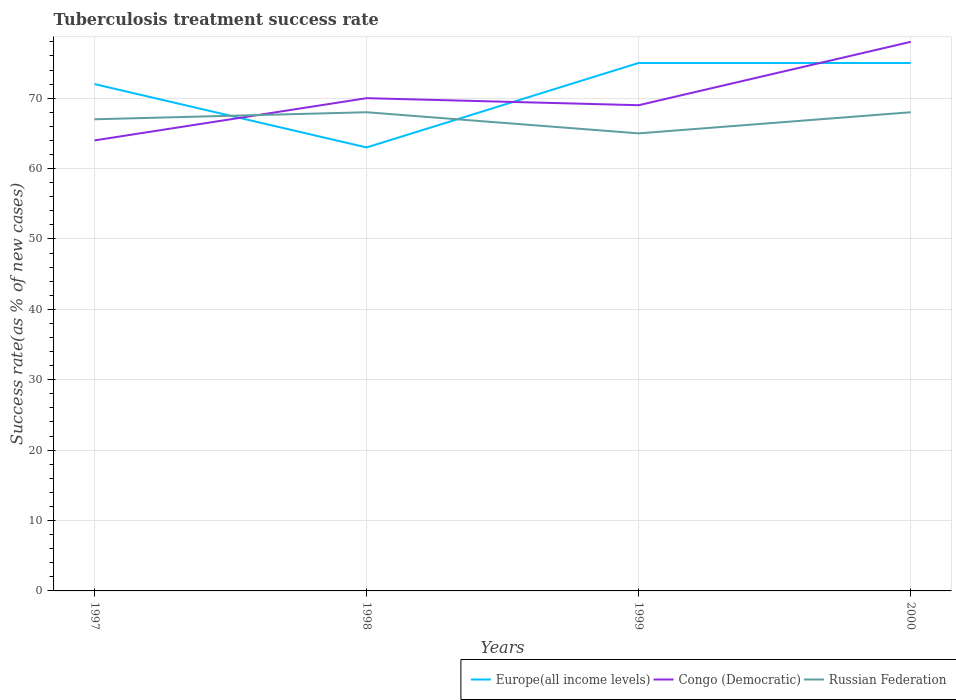Does the line corresponding to Congo (Democratic) intersect with the line corresponding to Russian Federation?
Your answer should be compact. Yes. Is the number of lines equal to the number of legend labels?
Your answer should be very brief. Yes. In which year was the tuberculosis treatment success rate in Europe(all income levels) maximum?
Make the answer very short. 1998. What is the total tuberculosis treatment success rate in Russian Federation in the graph?
Provide a short and direct response. -1. Is the tuberculosis treatment success rate in Europe(all income levels) strictly greater than the tuberculosis treatment success rate in Congo (Democratic) over the years?
Provide a succinct answer. No. How many years are there in the graph?
Provide a short and direct response. 4. What is the difference between two consecutive major ticks on the Y-axis?
Provide a succinct answer. 10. Are the values on the major ticks of Y-axis written in scientific E-notation?
Make the answer very short. No. Does the graph contain any zero values?
Your answer should be compact. No. Does the graph contain grids?
Offer a terse response. Yes. How are the legend labels stacked?
Your response must be concise. Horizontal. What is the title of the graph?
Ensure brevity in your answer.  Tuberculosis treatment success rate. Does "Uganda" appear as one of the legend labels in the graph?
Provide a short and direct response. No. What is the label or title of the Y-axis?
Provide a succinct answer. Success rate(as % of new cases). What is the Success rate(as % of new cases) in Europe(all income levels) in 1997?
Provide a succinct answer. 72. What is the Success rate(as % of new cases) of Congo (Democratic) in 1997?
Your answer should be compact. 64. What is the Success rate(as % of new cases) of Russian Federation in 1998?
Your response must be concise. 68. What is the Success rate(as % of new cases) of Congo (Democratic) in 1999?
Give a very brief answer. 69. What is the Success rate(as % of new cases) in Russian Federation in 1999?
Your answer should be very brief. 65. What is the Success rate(as % of new cases) in Congo (Democratic) in 2000?
Provide a succinct answer. 78. What is the Success rate(as % of new cases) of Russian Federation in 2000?
Your response must be concise. 68. Across all years, what is the minimum Success rate(as % of new cases) in Europe(all income levels)?
Provide a short and direct response. 63. Across all years, what is the minimum Success rate(as % of new cases) in Congo (Democratic)?
Ensure brevity in your answer.  64. Across all years, what is the minimum Success rate(as % of new cases) of Russian Federation?
Make the answer very short. 65. What is the total Success rate(as % of new cases) in Europe(all income levels) in the graph?
Give a very brief answer. 285. What is the total Success rate(as % of new cases) of Congo (Democratic) in the graph?
Provide a short and direct response. 281. What is the total Success rate(as % of new cases) in Russian Federation in the graph?
Provide a succinct answer. 268. What is the difference between the Success rate(as % of new cases) in Europe(all income levels) in 1997 and that in 1998?
Give a very brief answer. 9. What is the difference between the Success rate(as % of new cases) of Russian Federation in 1997 and that in 1998?
Provide a succinct answer. -1. What is the difference between the Success rate(as % of new cases) of Russian Federation in 1997 and that in 1999?
Your response must be concise. 2. What is the difference between the Success rate(as % of new cases) in Europe(all income levels) in 1997 and that in 2000?
Provide a succinct answer. -3. What is the difference between the Success rate(as % of new cases) in Congo (Democratic) in 1997 and that in 2000?
Make the answer very short. -14. What is the difference between the Success rate(as % of new cases) in Europe(all income levels) in 1998 and that in 1999?
Offer a very short reply. -12. What is the difference between the Success rate(as % of new cases) of Congo (Democratic) in 1998 and that in 1999?
Provide a short and direct response. 1. What is the difference between the Success rate(as % of new cases) of Europe(all income levels) in 1998 and that in 2000?
Make the answer very short. -12. What is the difference between the Success rate(as % of new cases) in Europe(all income levels) in 1999 and that in 2000?
Give a very brief answer. 0. What is the difference between the Success rate(as % of new cases) in Congo (Democratic) in 1999 and that in 2000?
Offer a terse response. -9. What is the difference between the Success rate(as % of new cases) of Europe(all income levels) in 1997 and the Success rate(as % of new cases) of Russian Federation in 1998?
Offer a terse response. 4. What is the difference between the Success rate(as % of new cases) in Congo (Democratic) in 1997 and the Success rate(as % of new cases) in Russian Federation in 1998?
Provide a short and direct response. -4. What is the difference between the Success rate(as % of new cases) in Europe(all income levels) in 1997 and the Success rate(as % of new cases) in Congo (Democratic) in 1999?
Your response must be concise. 3. What is the difference between the Success rate(as % of new cases) in Congo (Democratic) in 1997 and the Success rate(as % of new cases) in Russian Federation in 1999?
Keep it short and to the point. -1. What is the difference between the Success rate(as % of new cases) of Europe(all income levels) in 1997 and the Success rate(as % of new cases) of Congo (Democratic) in 2000?
Give a very brief answer. -6. What is the difference between the Success rate(as % of new cases) of Congo (Democratic) in 1997 and the Success rate(as % of new cases) of Russian Federation in 2000?
Offer a terse response. -4. What is the difference between the Success rate(as % of new cases) of Europe(all income levels) in 1998 and the Success rate(as % of new cases) of Congo (Democratic) in 1999?
Give a very brief answer. -6. What is the difference between the Success rate(as % of new cases) of Congo (Democratic) in 1998 and the Success rate(as % of new cases) of Russian Federation in 1999?
Offer a terse response. 5. What is the difference between the Success rate(as % of new cases) of Europe(all income levels) in 1998 and the Success rate(as % of new cases) of Russian Federation in 2000?
Your response must be concise. -5. What is the difference between the Success rate(as % of new cases) of Congo (Democratic) in 1998 and the Success rate(as % of new cases) of Russian Federation in 2000?
Provide a succinct answer. 2. What is the difference between the Success rate(as % of new cases) in Europe(all income levels) in 1999 and the Success rate(as % of new cases) in Congo (Democratic) in 2000?
Provide a succinct answer. -3. What is the difference between the Success rate(as % of new cases) in Congo (Democratic) in 1999 and the Success rate(as % of new cases) in Russian Federation in 2000?
Provide a succinct answer. 1. What is the average Success rate(as % of new cases) in Europe(all income levels) per year?
Offer a very short reply. 71.25. What is the average Success rate(as % of new cases) in Congo (Democratic) per year?
Ensure brevity in your answer.  70.25. In the year 1997, what is the difference between the Success rate(as % of new cases) of Europe(all income levels) and Success rate(as % of new cases) of Congo (Democratic)?
Keep it short and to the point. 8. In the year 1997, what is the difference between the Success rate(as % of new cases) of Europe(all income levels) and Success rate(as % of new cases) of Russian Federation?
Make the answer very short. 5. In the year 1998, what is the difference between the Success rate(as % of new cases) of Europe(all income levels) and Success rate(as % of new cases) of Congo (Democratic)?
Give a very brief answer. -7. In the year 1998, what is the difference between the Success rate(as % of new cases) of Congo (Democratic) and Success rate(as % of new cases) of Russian Federation?
Give a very brief answer. 2. In the year 1999, what is the difference between the Success rate(as % of new cases) of Europe(all income levels) and Success rate(as % of new cases) of Congo (Democratic)?
Provide a succinct answer. 6. In the year 1999, what is the difference between the Success rate(as % of new cases) in Congo (Democratic) and Success rate(as % of new cases) in Russian Federation?
Offer a terse response. 4. In the year 2000, what is the difference between the Success rate(as % of new cases) of Europe(all income levels) and Success rate(as % of new cases) of Congo (Democratic)?
Make the answer very short. -3. What is the ratio of the Success rate(as % of new cases) of Congo (Democratic) in 1997 to that in 1998?
Your response must be concise. 0.91. What is the ratio of the Success rate(as % of new cases) of Europe(all income levels) in 1997 to that in 1999?
Your answer should be very brief. 0.96. What is the ratio of the Success rate(as % of new cases) of Congo (Democratic) in 1997 to that in 1999?
Your answer should be compact. 0.93. What is the ratio of the Success rate(as % of new cases) in Russian Federation in 1997 to that in 1999?
Give a very brief answer. 1.03. What is the ratio of the Success rate(as % of new cases) in Europe(all income levels) in 1997 to that in 2000?
Ensure brevity in your answer.  0.96. What is the ratio of the Success rate(as % of new cases) of Congo (Democratic) in 1997 to that in 2000?
Provide a succinct answer. 0.82. What is the ratio of the Success rate(as % of new cases) of Russian Federation in 1997 to that in 2000?
Give a very brief answer. 0.99. What is the ratio of the Success rate(as % of new cases) of Europe(all income levels) in 1998 to that in 1999?
Offer a very short reply. 0.84. What is the ratio of the Success rate(as % of new cases) in Congo (Democratic) in 1998 to that in 1999?
Provide a short and direct response. 1.01. What is the ratio of the Success rate(as % of new cases) of Russian Federation in 1998 to that in 1999?
Provide a succinct answer. 1.05. What is the ratio of the Success rate(as % of new cases) of Europe(all income levels) in 1998 to that in 2000?
Your answer should be compact. 0.84. What is the ratio of the Success rate(as % of new cases) of Congo (Democratic) in 1998 to that in 2000?
Offer a terse response. 0.9. What is the ratio of the Success rate(as % of new cases) in Congo (Democratic) in 1999 to that in 2000?
Provide a succinct answer. 0.88. What is the ratio of the Success rate(as % of new cases) in Russian Federation in 1999 to that in 2000?
Provide a succinct answer. 0.96. What is the difference between the highest and the second highest Success rate(as % of new cases) in Congo (Democratic)?
Provide a short and direct response. 8. What is the difference between the highest and the second highest Success rate(as % of new cases) in Russian Federation?
Your answer should be compact. 0. What is the difference between the highest and the lowest Success rate(as % of new cases) in Congo (Democratic)?
Offer a very short reply. 14. 